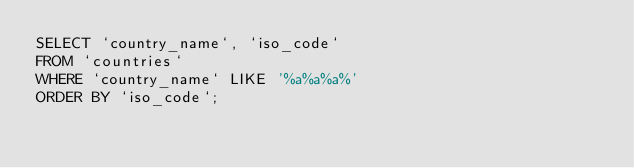Convert code to text. <code><loc_0><loc_0><loc_500><loc_500><_SQL_>SELECT `country_name`, `iso_code`
FROM `countries`
WHERE `country_name` LIKE '%a%a%a%'
ORDER BY `iso_code`;</code> 